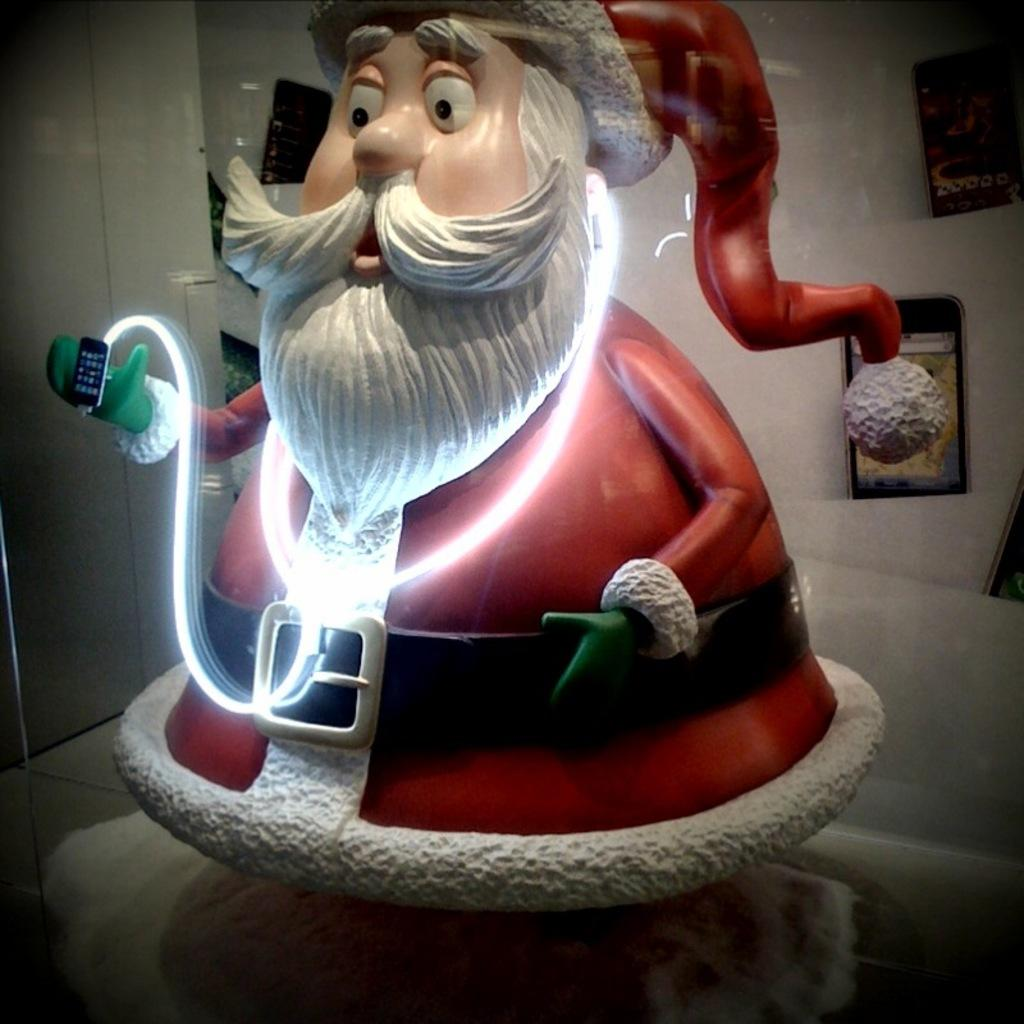What is the main subject of the image? The main subject of the image is a toy Santa. What is the toy Santa holding? The toy Santa is holding a mobile. How many mobiles can be seen in the image? There are multiple mobiles visible in the image. What is the color of the surface on which the mobiles are placed? The surface on which the mobiles are placed is white. What type of wax is being used to create the ground in the image? There is no mention of wax or ground in the image; it features a toy Santa holding a mobile on a white surface. 